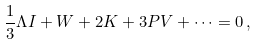Convert formula to latex. <formula><loc_0><loc_0><loc_500><loc_500>\frac { 1 } { 3 } \Lambda I + W + 2 K + 3 P V + \dots = 0 \, ,</formula> 